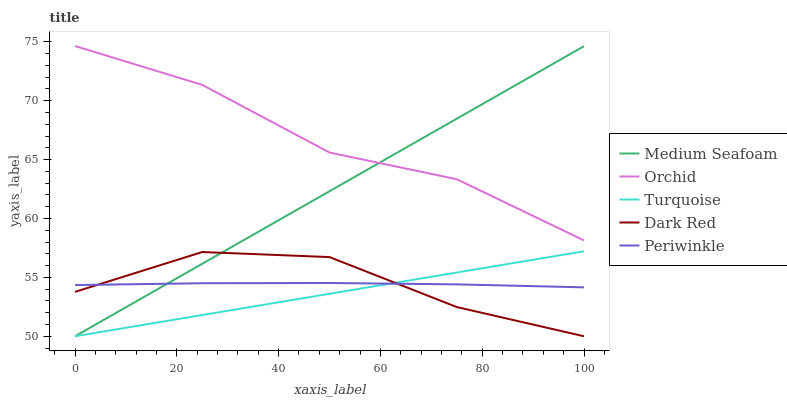Does Turquoise have the minimum area under the curve?
Answer yes or no. Yes. Does Orchid have the maximum area under the curve?
Answer yes or no. Yes. Does Periwinkle have the minimum area under the curve?
Answer yes or no. No. Does Periwinkle have the maximum area under the curve?
Answer yes or no. No. Is Medium Seafoam the smoothest?
Answer yes or no. Yes. Is Dark Red the roughest?
Answer yes or no. Yes. Is Turquoise the smoothest?
Answer yes or no. No. Is Turquoise the roughest?
Answer yes or no. No. Does Dark Red have the lowest value?
Answer yes or no. Yes. Does Periwinkle have the lowest value?
Answer yes or no. No. Does Orchid have the highest value?
Answer yes or no. Yes. Does Turquoise have the highest value?
Answer yes or no. No. Is Periwinkle less than Orchid?
Answer yes or no. Yes. Is Orchid greater than Turquoise?
Answer yes or no. Yes. Does Dark Red intersect Turquoise?
Answer yes or no. Yes. Is Dark Red less than Turquoise?
Answer yes or no. No. Is Dark Red greater than Turquoise?
Answer yes or no. No. Does Periwinkle intersect Orchid?
Answer yes or no. No. 